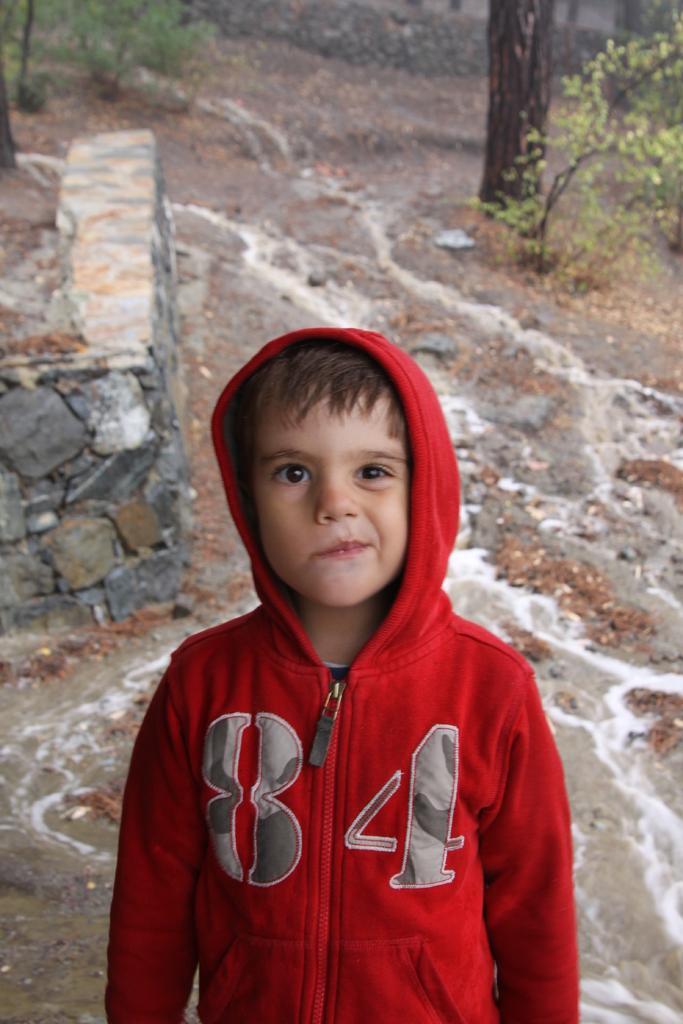How would you summarize this image in a sentence or two? In this image I can see a boy is standing and wearing a red color hoodie. In the background I can see a tree and plants. 